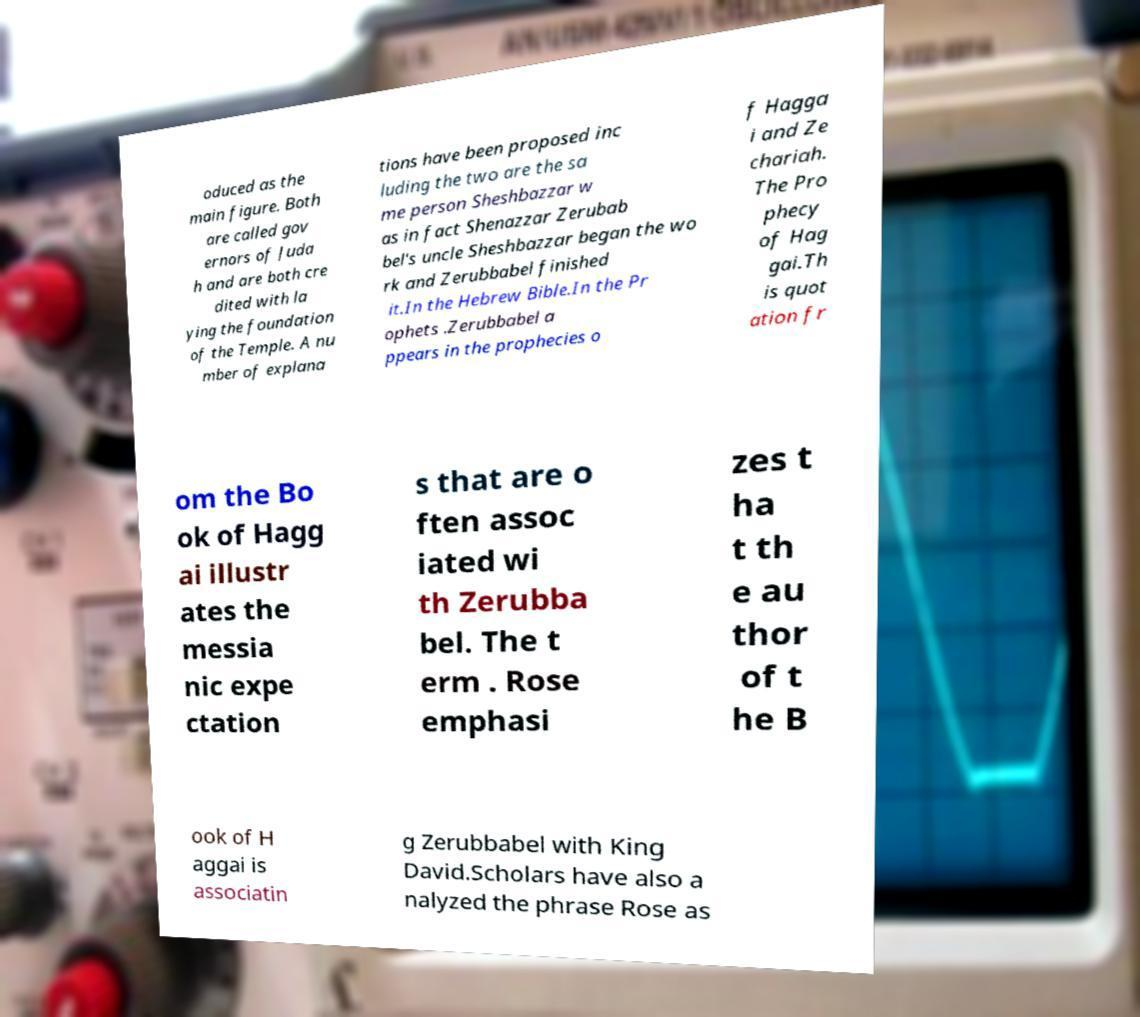Can you read and provide the text displayed in the image?This photo seems to have some interesting text. Can you extract and type it out for me? oduced as the main figure. Both are called gov ernors of Juda h and are both cre dited with la ying the foundation of the Temple. A nu mber of explana tions have been proposed inc luding the two are the sa me person Sheshbazzar w as in fact Shenazzar Zerubab bel's uncle Sheshbazzar began the wo rk and Zerubbabel finished it.In the Hebrew Bible.In the Pr ophets .Zerubbabel a ppears in the prophecies o f Hagga i and Ze chariah. The Pro phecy of Hag gai.Th is quot ation fr om the Bo ok of Hagg ai illustr ates the messia nic expe ctation s that are o ften assoc iated wi th Zerubba bel. The t erm . Rose emphasi zes t ha t th e au thor of t he B ook of H aggai is associatin g Zerubbabel with King David.Scholars have also a nalyzed the phrase Rose as 